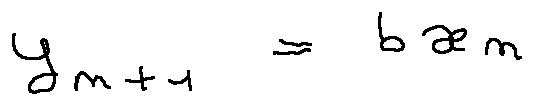<formula> <loc_0><loc_0><loc_500><loc_500>y _ { n + 1 } = b x _ { n }</formula> 